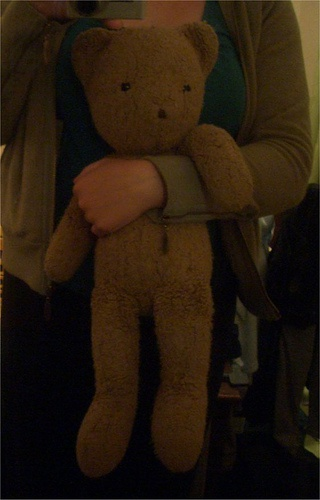Describe the objects in this image and their specific colors. I can see people in gray, black, maroon, and olive tones and teddy bear in black, maroon, and gray tones in this image. 